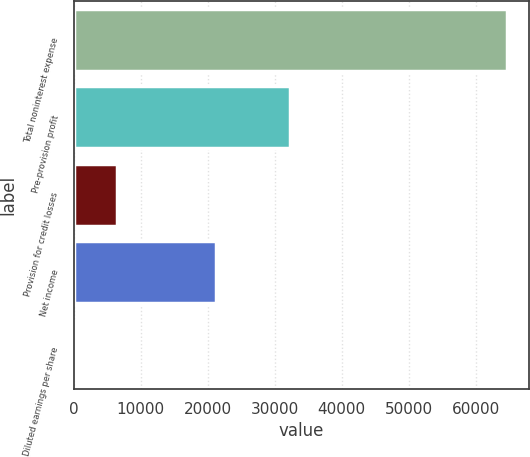Convert chart. <chart><loc_0><loc_0><loc_500><loc_500><bar_chart><fcel>Total noninterest expense<fcel>Pre-provision profit<fcel>Provision for credit losses<fcel>Net income<fcel>Diluted earnings per share<nl><fcel>64729<fcel>32302<fcel>6477.58<fcel>21284<fcel>5.2<nl></chart> 